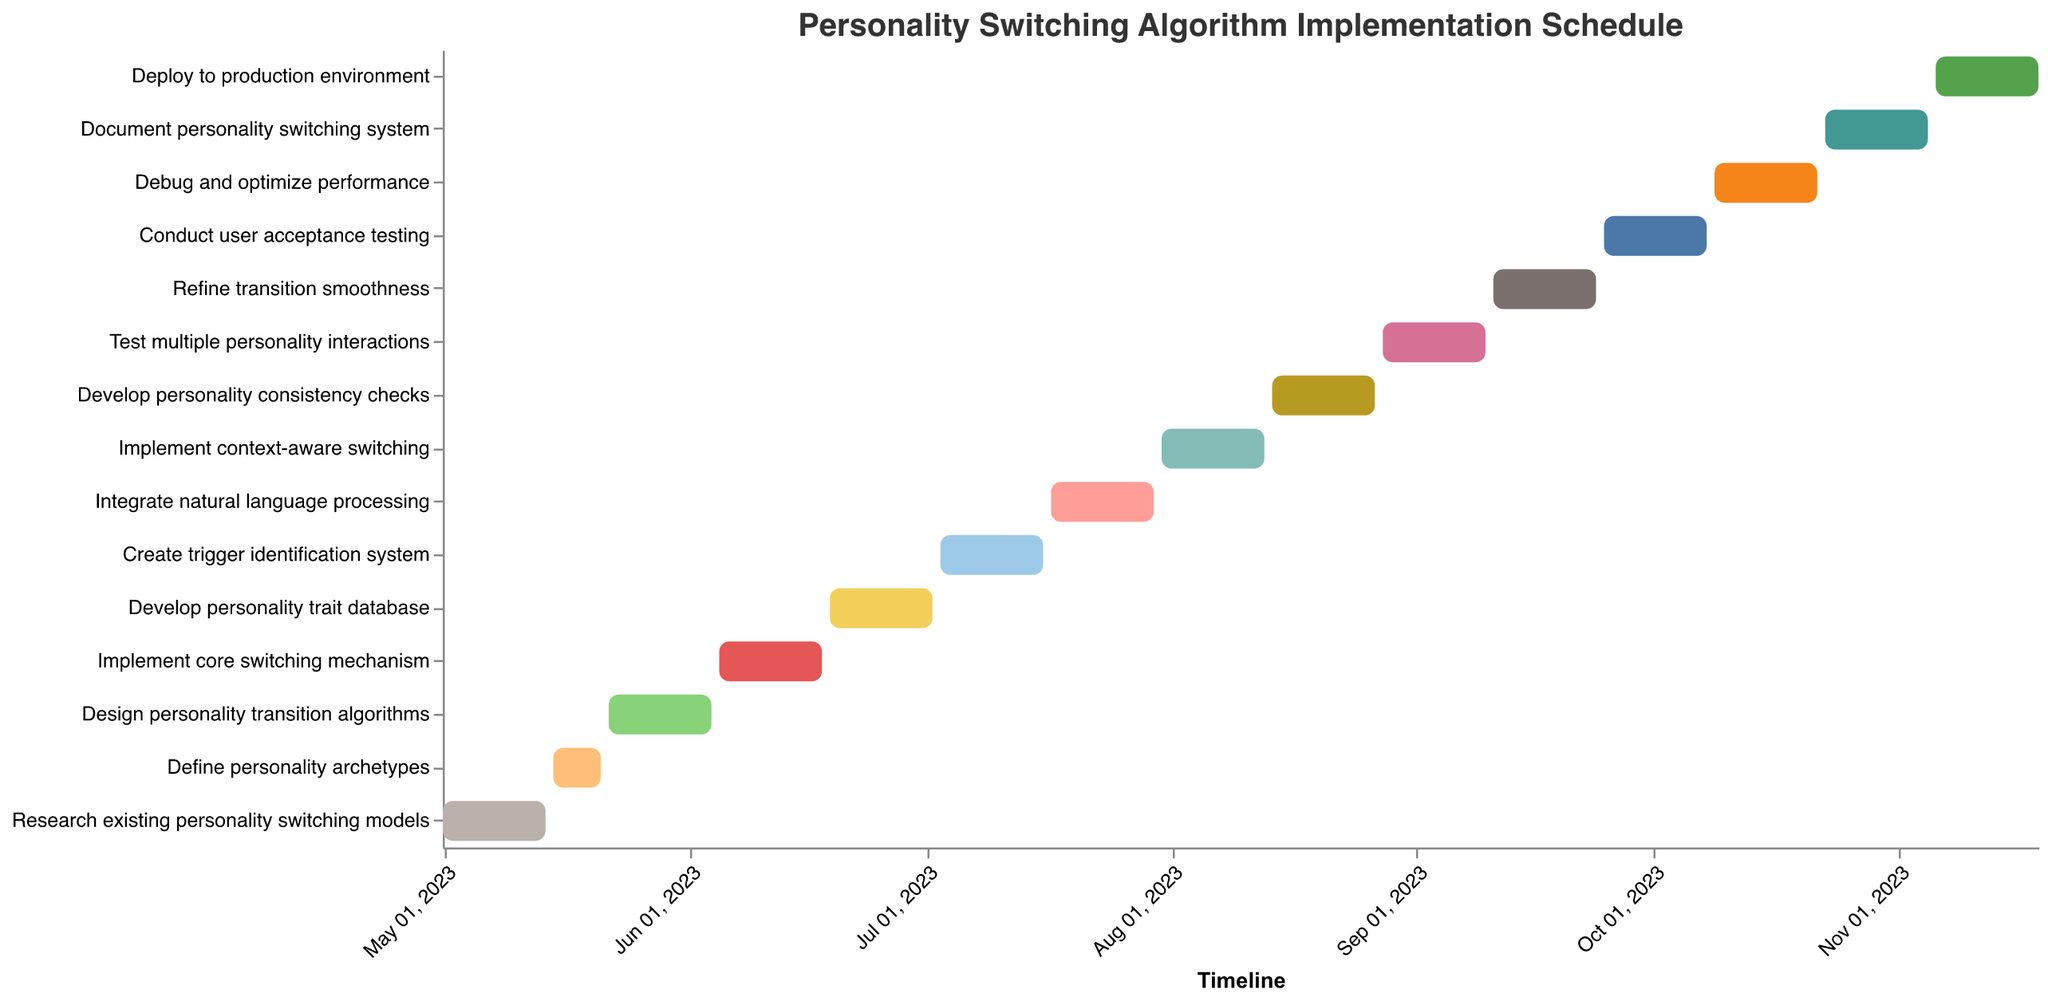What is the total duration of the task "Implement core switching mechanism"? The task "Implement core switching mechanism" starts on 2023-06-05 and ends on 2023-06-18, giving it a duration of 14 days.
Answer: 14 days Which task starts immediately after "Create trigger identification system"? The task "Create trigger identification system" ends on 2023-07-16, and the task that starts immediately after is "Integrate natural language processing", which starts on 2023-07-17.
Answer: Integrate natural language processing How many tasks are scheduled to start and end in September 2023? Tasks scheduled in September 2023 include "Refine transition smoothness" from 2023-09-11 to 2023-09-24 and "Conduct user acceptance testing" from 2023-09-25 to 2023-10-08. Therefore, only the task "Refine transition smoothness" fully fits within September, resulting in 1 task.
Answer: 1 Which task has the shortest duration, and what is its duration? The task "Define personality archetypes" has the shortest duration, lasting for 7 days from 2023-05-15 to 2023-05-21.
Answer: Define personality archetypes, 7 days How many tasks are scheduled to be executed in parallel in August 2023? In August 2023, the tasks "Implement context-aware switching" (2023-07-31 to 2023-08-13), "Develop personality consistency checks" (2023-08-14 to 2023-08-27), and "Test multiple personality interactions" (2023-08-28 to 2023-09-10) overlap, meaning that there are periods with multiple tasks being executed simultaneously.
Answer: 3 tasks When does the task "Debug and optimize performance" end? The task "Debug and optimize performance" starts on 2023-10-09 and ends on 2023-10-22.
Answer: 2023-10-22 What is the first task scheduled in July 2023, and what is its duration? The first task scheduled in July 2023 is "Create trigger identification system", which starts on 2023-07-03 and ends on 2023-07-16, giving it a duration of 14 days.
Answer: Create trigger identification system, 14 days Which task has the longest duration in the Gantt Chart? The longest duration task in the Gantt Chart is "Research existing personality switching models", "Design personality transition algorithms", "Implement core switching mechanism", "Develop personality trait database", "Create trigger identification system", "Integrate natural language processing", "Implement context-aware switching", "Develop personality consistency checks", "Test multiple personality interactions", "Refine transition smoothness", "Conduct user acceptance testing", "Debug and optimize performance", "Document personality switching system" and "Deploy to production environment" with a duration of 14 days. They all share the same duration.
Answer: Multiple tasks (14 days each) 